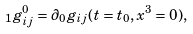Convert formula to latex. <formula><loc_0><loc_0><loc_500><loc_500>\ _ { 1 } g ^ { 0 } _ { i j } = \partial _ { 0 } g _ { i j } ( t = t _ { 0 } , x ^ { 3 } = 0 ) ,</formula> 